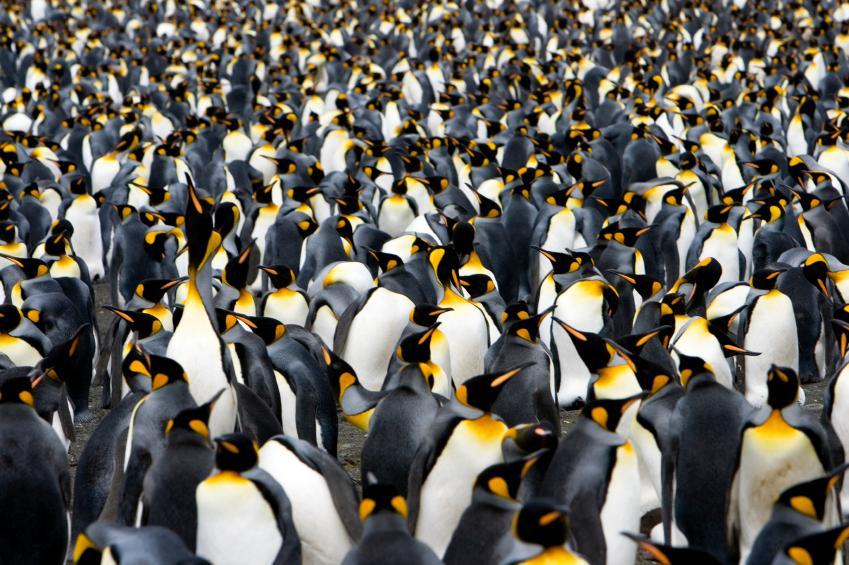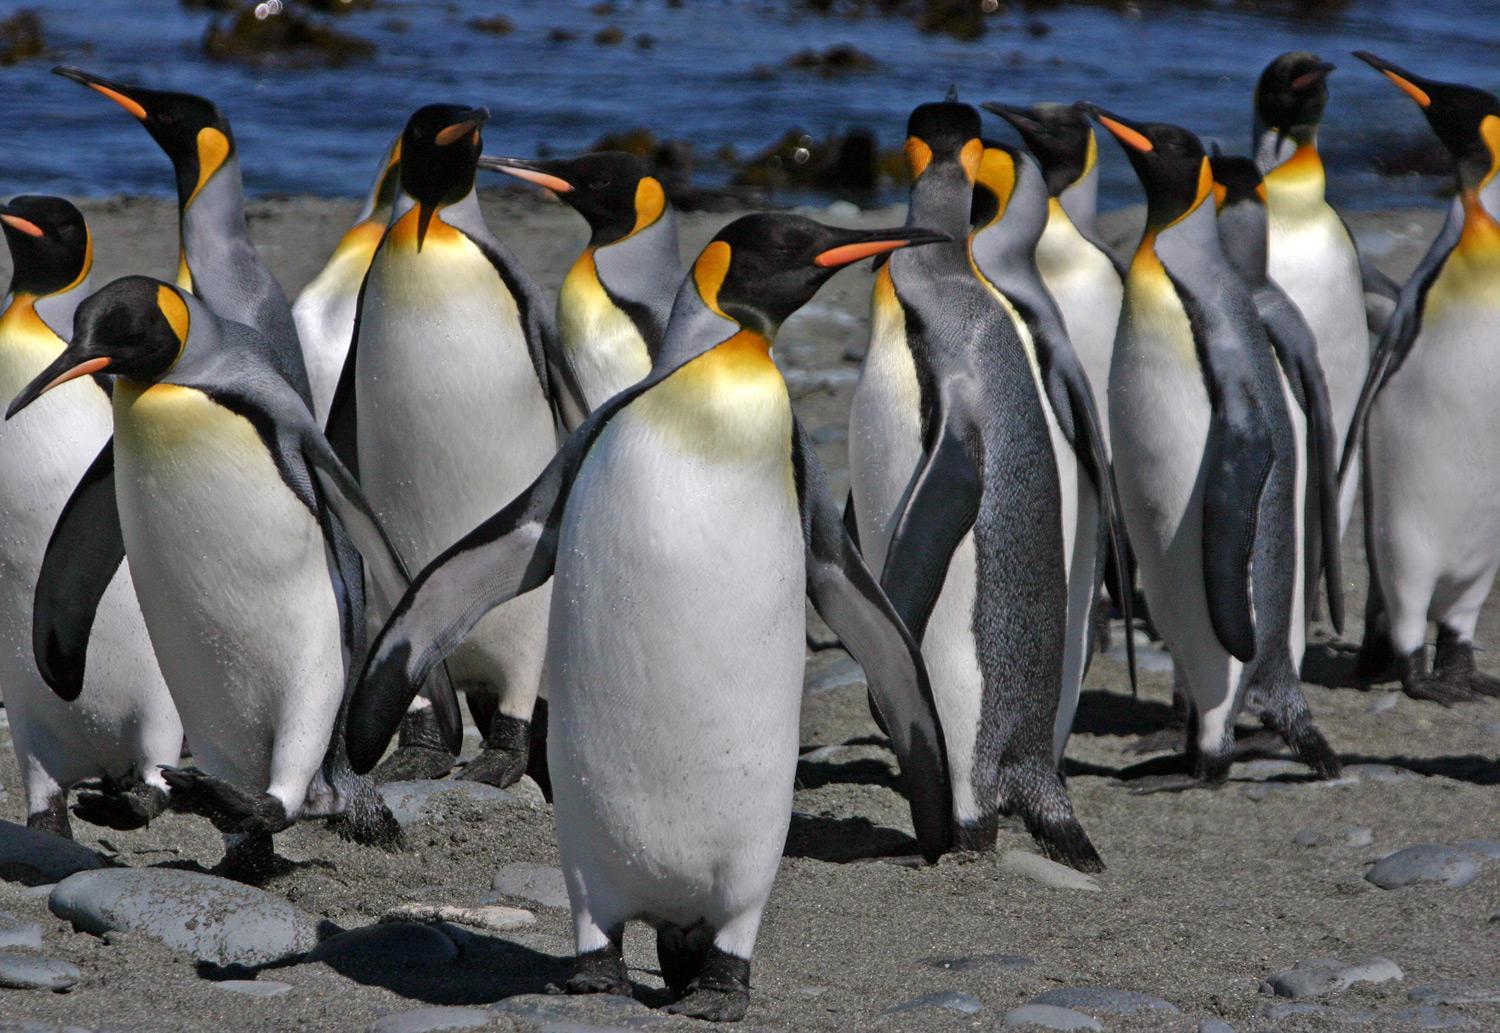The first image is the image on the left, the second image is the image on the right. Assess this claim about the two images: "One image shows just two penguins side-by-side, with faces turned inward.". Correct or not? Answer yes or no. No. The first image is the image on the left, the second image is the image on the right. Considering the images on both sides, is "There are two penguins in the left image" valid? Answer yes or no. No. 